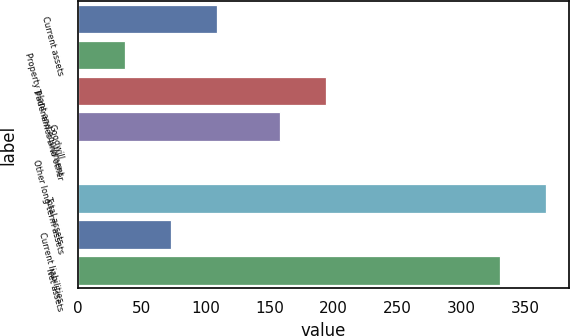<chart> <loc_0><loc_0><loc_500><loc_500><bar_chart><fcel>Current assets<fcel>Property plant and equipment<fcel>Tradenames and other<fcel>Goodwill<fcel>Other long-term assets<fcel>Total assets<fcel>Current liabilities<fcel>Net assets<nl><fcel>108.81<fcel>36.47<fcel>194.27<fcel>158.1<fcel>0.3<fcel>365.97<fcel>72.64<fcel>329.8<nl></chart> 